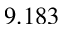Convert formula to latex. <formula><loc_0><loc_0><loc_500><loc_500>9 . 1 8 3</formula> 